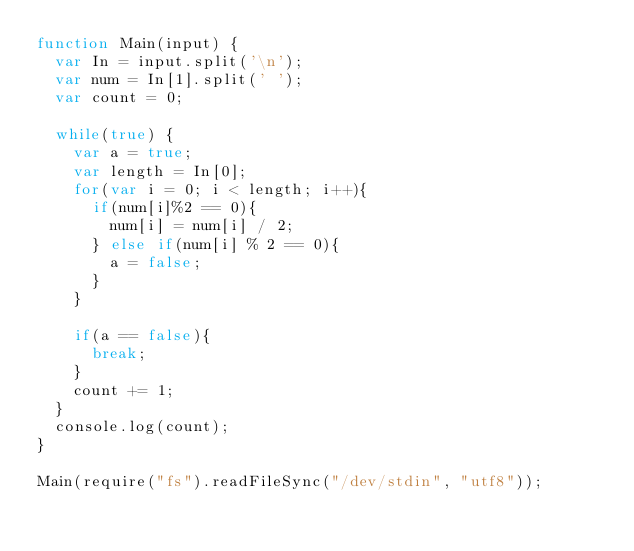Convert code to text. <code><loc_0><loc_0><loc_500><loc_500><_JavaScript_>function Main(input) {
  var In = input.split('\n');
  var num = In[1].split(' ');
  var count = 0;
  
  while(true) {
    var a = true;
    var length = In[0];
    for(var i = 0; i < length; i++){
      if(num[i]%2 == 0){
        num[i] = num[i] / 2;
      } else if(num[i] % 2 == 0){
        a = false;
      }
    }
    
    if(a == false){
      break;
    }
    count += 1;
  }
  console.log(count);
}

Main(require("fs").readFileSync("/dev/stdin", "utf8"));</code> 